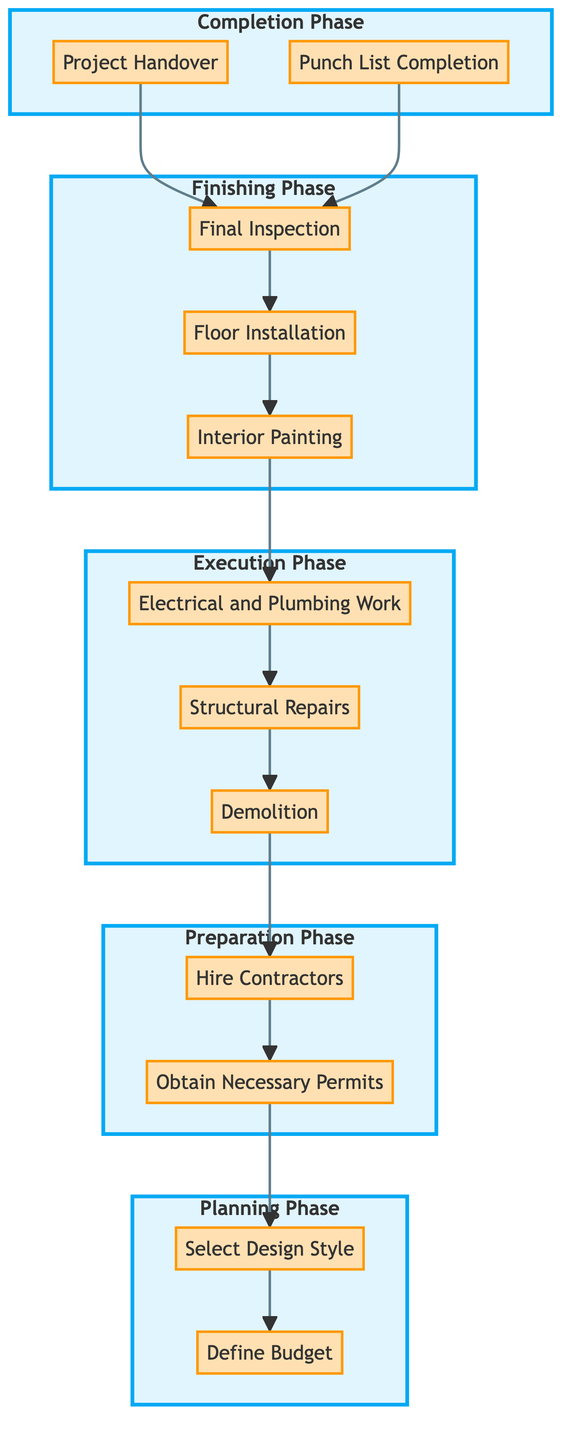What is the first task in the Planning Phase? The first task in the Planning Phase is "Define Budget". I locate the Planning Phase in the diagram, and the first task listed under it is "Define Budget".
Answer: Define Budget How many tasks are in the Execution Phase? In the Execution Phase, there are three tasks: "Demolition", "Structural Repairs", and "Electrical and Plumbing Work". I count the tasks listed under the Execution Phase subgraph.
Answer: 3 What task depends on "Select Design Style"? The task that depends on "Select Design Style" is "Obtain Necessary Permits". I follow the arrow from "Select Design Style" to determine which task relies on it.
Answer: Obtain Necessary Permits Which task is the final task before "Project Handover"? The final task before "Project Handover" is "Punch List Completion". I look at the connections leading into "Project Handover" and identify "Punch List Completion" as the immediate predecessor.
Answer: Punch List Completion What is the completion stage of "Interior Painting"? The completion stage of "Interior Painting" is "Not Started". I locate the task "Interior Painting" in the Finishing Phase and check its completion stage.
Answer: Not Started Which task has the most dependencies? The task with the most dependencies is "Electrical and Plumbing Work", which depends on "Structural Repairs", which in turn depends on "Demolition". Therefore, it has two layers of dependencies. I trace the dependencies of each task to find the one with the most.
Answer: Electrical and Plumbing Work How does one task connect to the next from "Define Budget" to "Punch List Completion"? The connection flow is: "Define Budget" → "Select Design Style" → "Obtain Necessary Permits" → "Hire Contractors" → "Demolition" → "Structural Repairs" → "Electrical and Plumbing Work" → "Interior Painting" → "Floor Installation" → "Final Inspection" → "Punch List Completion". I follow each connection forward from "Define Budget" to reach "Punch List Completion".
Answer: Multiple steps (10 tasks) What are the names of all tasks in the Finishing Phase? The names of all tasks in the Finishing Phase are: "Interior Painting", "Floor Installation", and "Final Inspection". I list all tasks under the Finishing Phase subgraph.
Answer: Interior Painting, Floor Installation, Final Inspection 